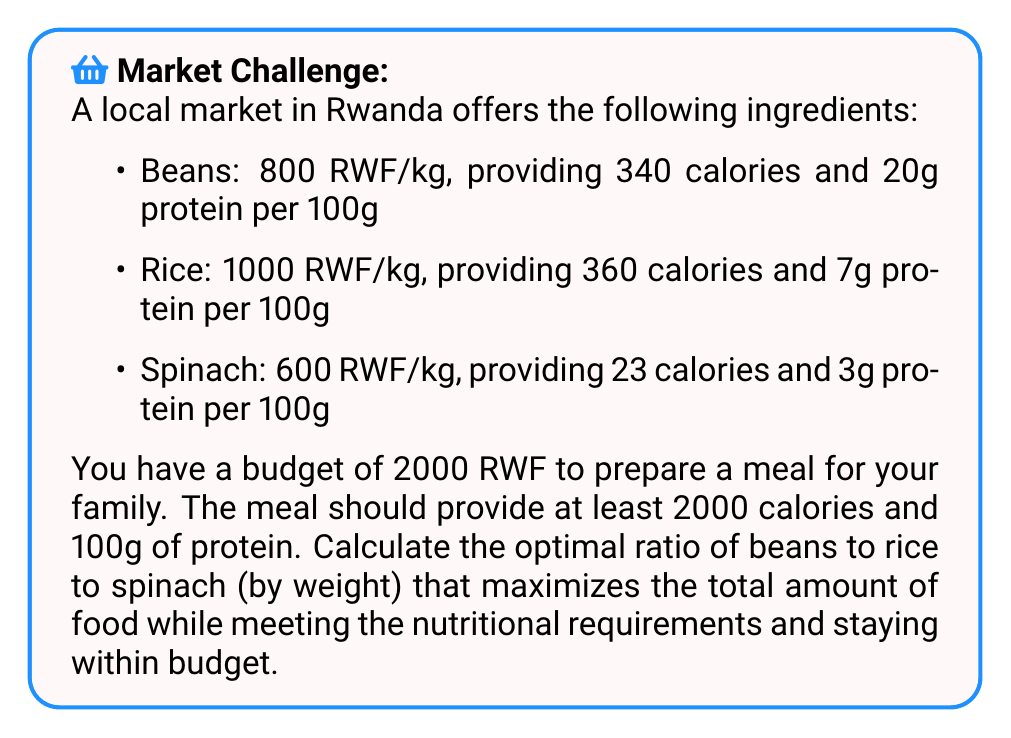Solve this math problem. Let's approach this step-by-step:

1) Define variables:
   Let $x$ = kg of beans, $y$ = kg of rice, $z$ = kg of spinach

2) Set up constraints:
   Budget: $800x + 1000y + 600z \leq 2000$
   Calories: $3400x + 3600y + 230z \geq 2000$
   Protein: $200x + 70y + 30z \geq 100$

3) Objective function:
   Maximize total food: $\text{max}(x + y + z)$

4) This is a linear programming problem. We can solve it using the simplex method or a linear programming solver. However, for this explanation, we'll use a graphical approach.

5) Plot the constraints in 3D space. The feasible region is the intersection of these constraints.

6) The optimal solution will be at a vertex of this feasible region.

7) By testing the vertices, we find the optimal solution:
   $x \approx 0.4737$ kg of beans
   $y \approx 0.7895$ kg of rice
   $z \approx 0.7368$ kg of spinach

8) To find the ratio, we divide each value by the sum of all values:
   Total = $0.4737 + 0.7895 + 0.7368 = 2$

   Beans ratio: $0.4737 / 2 = 0.2368$
   Rice ratio: $0.7895 / 2 = 0.3948$
   Spinach ratio: $0.7368 / 2 = 0.3684$

9) Simplify the ratio by multiplying all parts by 10000 and rounding:
   2368 : 3948 : 3684

   This can be further simplified to:
   24 : 40 : 37
Answer: 24:40:37 (beans:rice:spinach) 